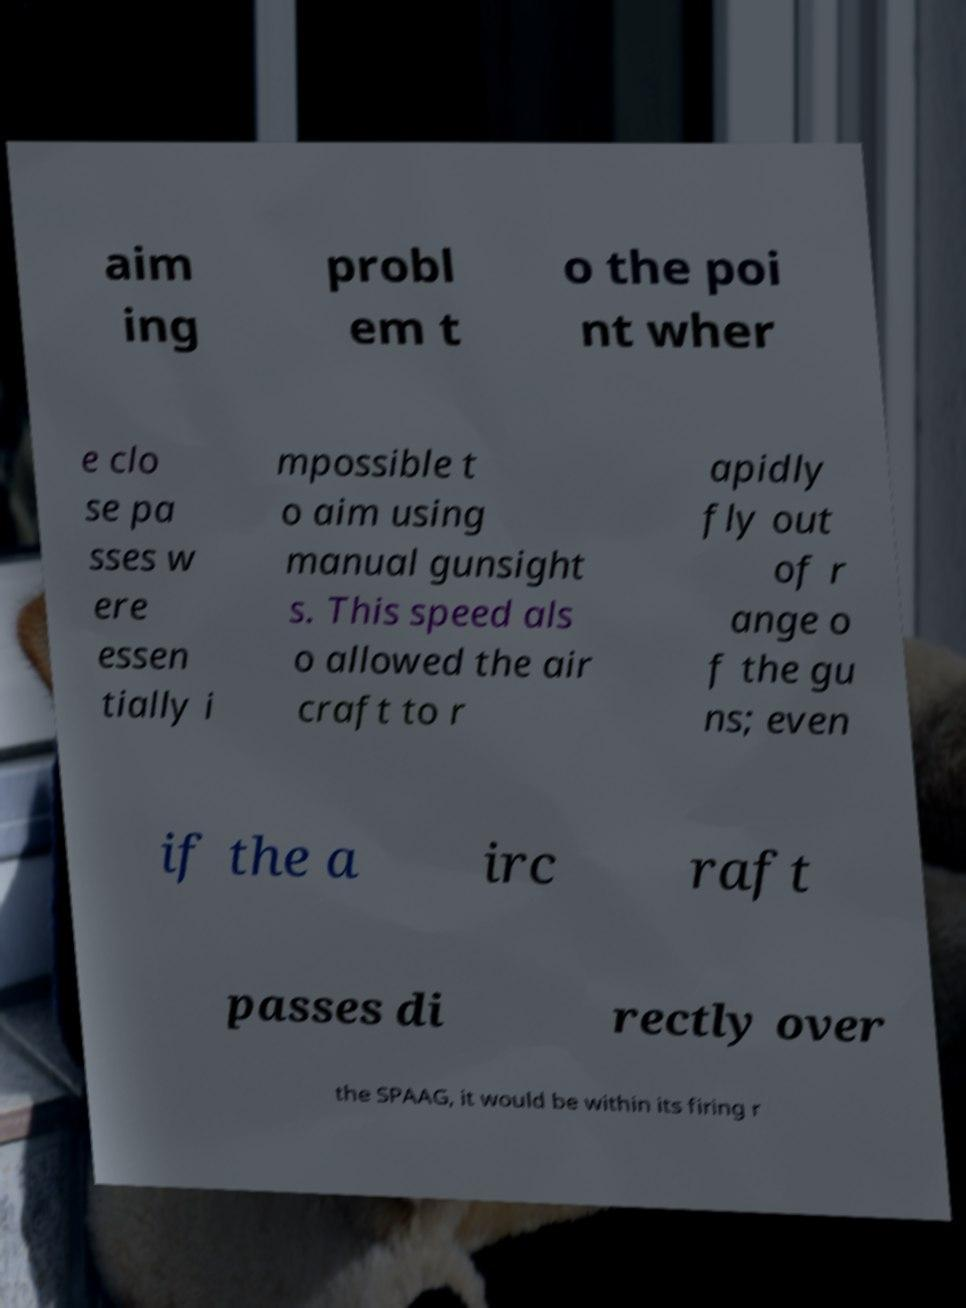Can you accurately transcribe the text from the provided image for me? aim ing probl em t o the poi nt wher e clo se pa sses w ere essen tially i mpossible t o aim using manual gunsight s. This speed als o allowed the air craft to r apidly fly out of r ange o f the gu ns; even if the a irc raft passes di rectly over the SPAAG, it would be within its firing r 